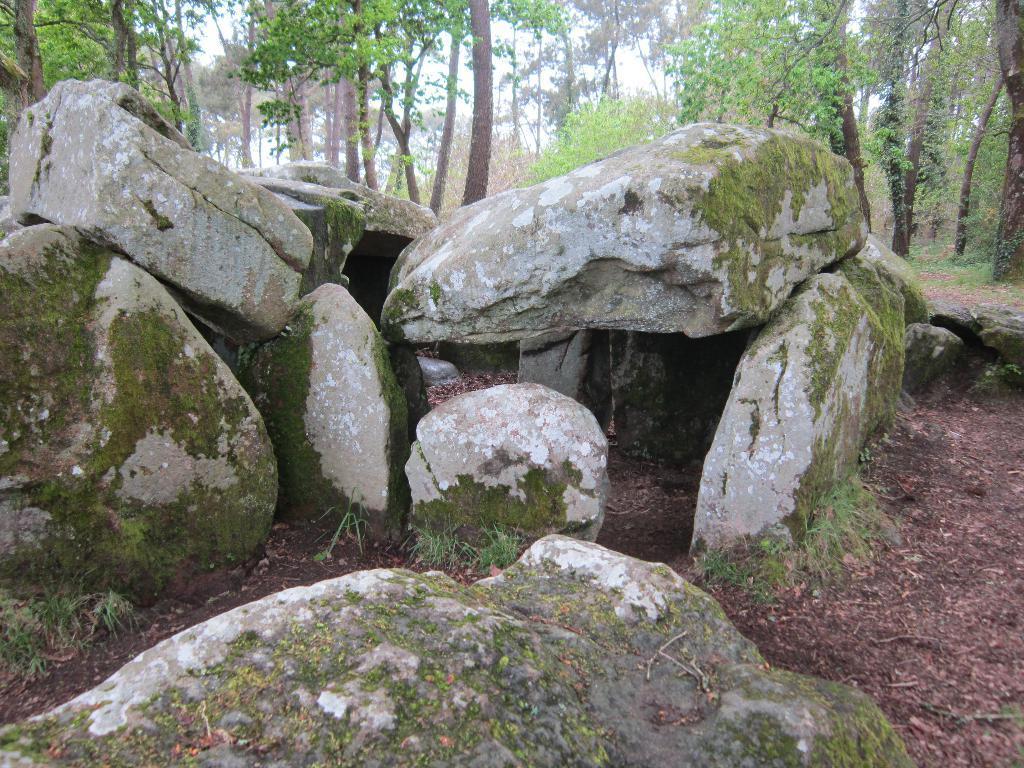Please provide a concise description of this image. in this picture we see some rocks and few trees around 